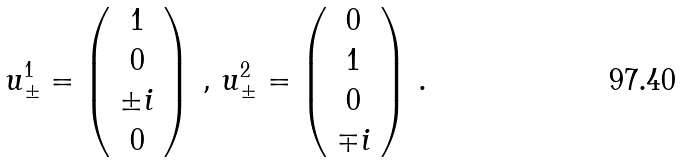<formula> <loc_0><loc_0><loc_500><loc_500>u _ { \pm } ^ { 1 } = \left ( \begin{array} { c } 1 \\ 0 \\ \pm i \\ 0 \end{array} \right ) \, , \, u _ { \pm } ^ { 2 } = \left ( \begin{array} { c } 0 \\ 1 \\ 0 \\ \mp i \end{array} \right ) \, .</formula> 